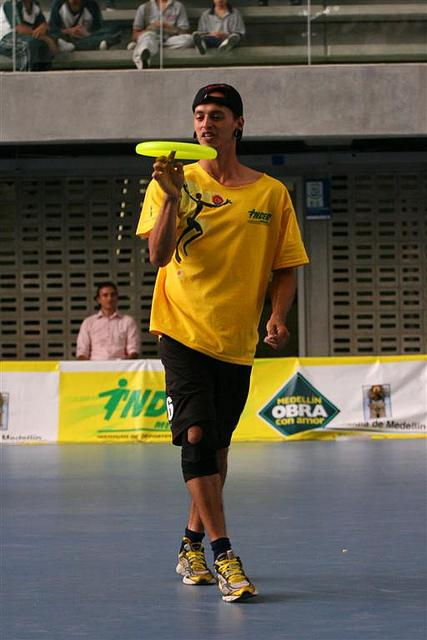The dominant color on the shirt is the same color as what food item?

Choices:
A) ketchup
B) mustard
C) salt
D) relish mustard 